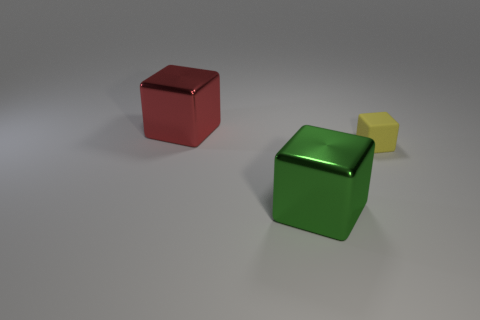Add 1 small yellow matte cubes. How many objects exist? 4 Subtract all big cubes. How many cubes are left? 1 Subtract all red blocks. How many blocks are left? 2 Subtract 0 red cylinders. How many objects are left? 3 Subtract 2 blocks. How many blocks are left? 1 Subtract all yellow cubes. Subtract all green spheres. How many cubes are left? 2 Subtract all yellow things. Subtract all yellow rubber objects. How many objects are left? 1 Add 2 shiny blocks. How many shiny blocks are left? 4 Add 3 large red objects. How many large red objects exist? 4 